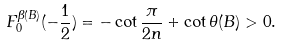Convert formula to latex. <formula><loc_0><loc_0><loc_500><loc_500>F _ { 0 } ^ { \beta ( B ) } ( - \frac { 1 } { 2 } ) = - \cot \frac { \pi } { 2 n } + \cot \theta ( B ) > 0 .</formula> 